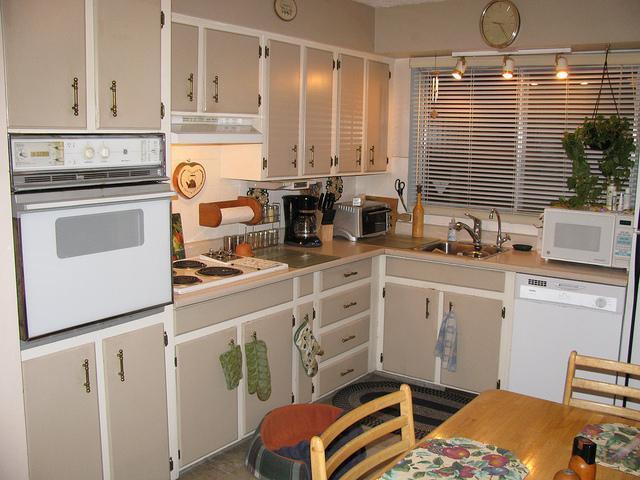How many oven mitts are hanging on cupboards?
Give a very brief answer. 3. How many potted plants are in the photo?
Give a very brief answer. 1. How many refrigerators are there?
Give a very brief answer. 2. How many chairs can you see?
Give a very brief answer. 2. How many bus riders are leaning out of a bus window?
Give a very brief answer. 0. 